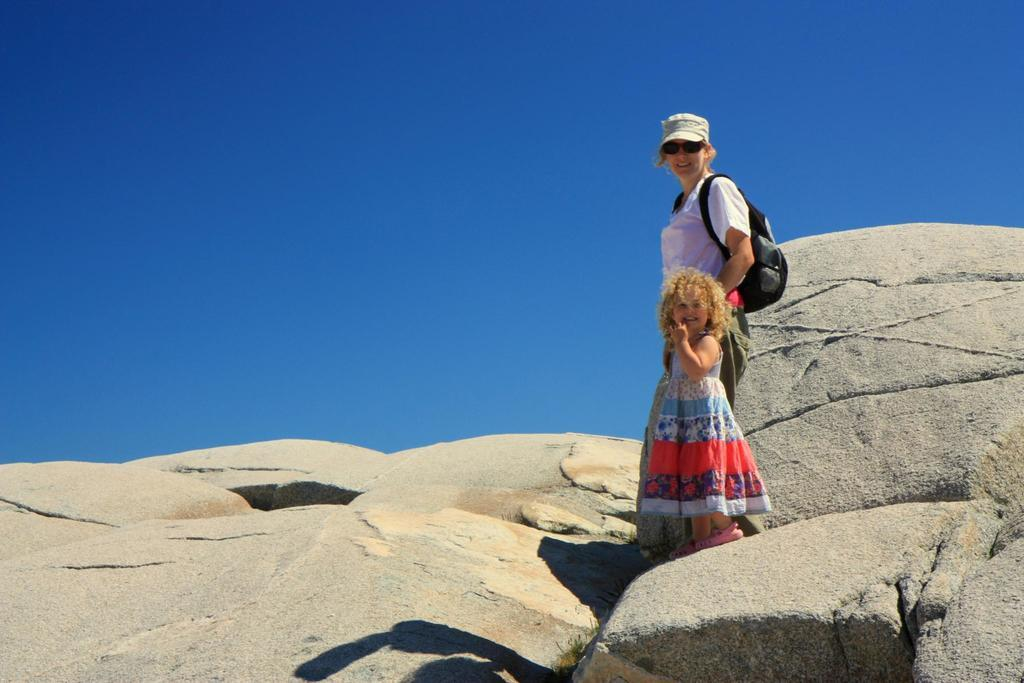Who is present in the image? There is a person and a kid in the image. Where are the person and the kid located? Both the person and the kid are on a rock hill. What can be seen in the background of the image? There is a sky visible in the background of the image. What type of quartz can be seen on the rock hill in the image? There is no quartz visible in the image; it only features a person, a kid, and a rock hill. 